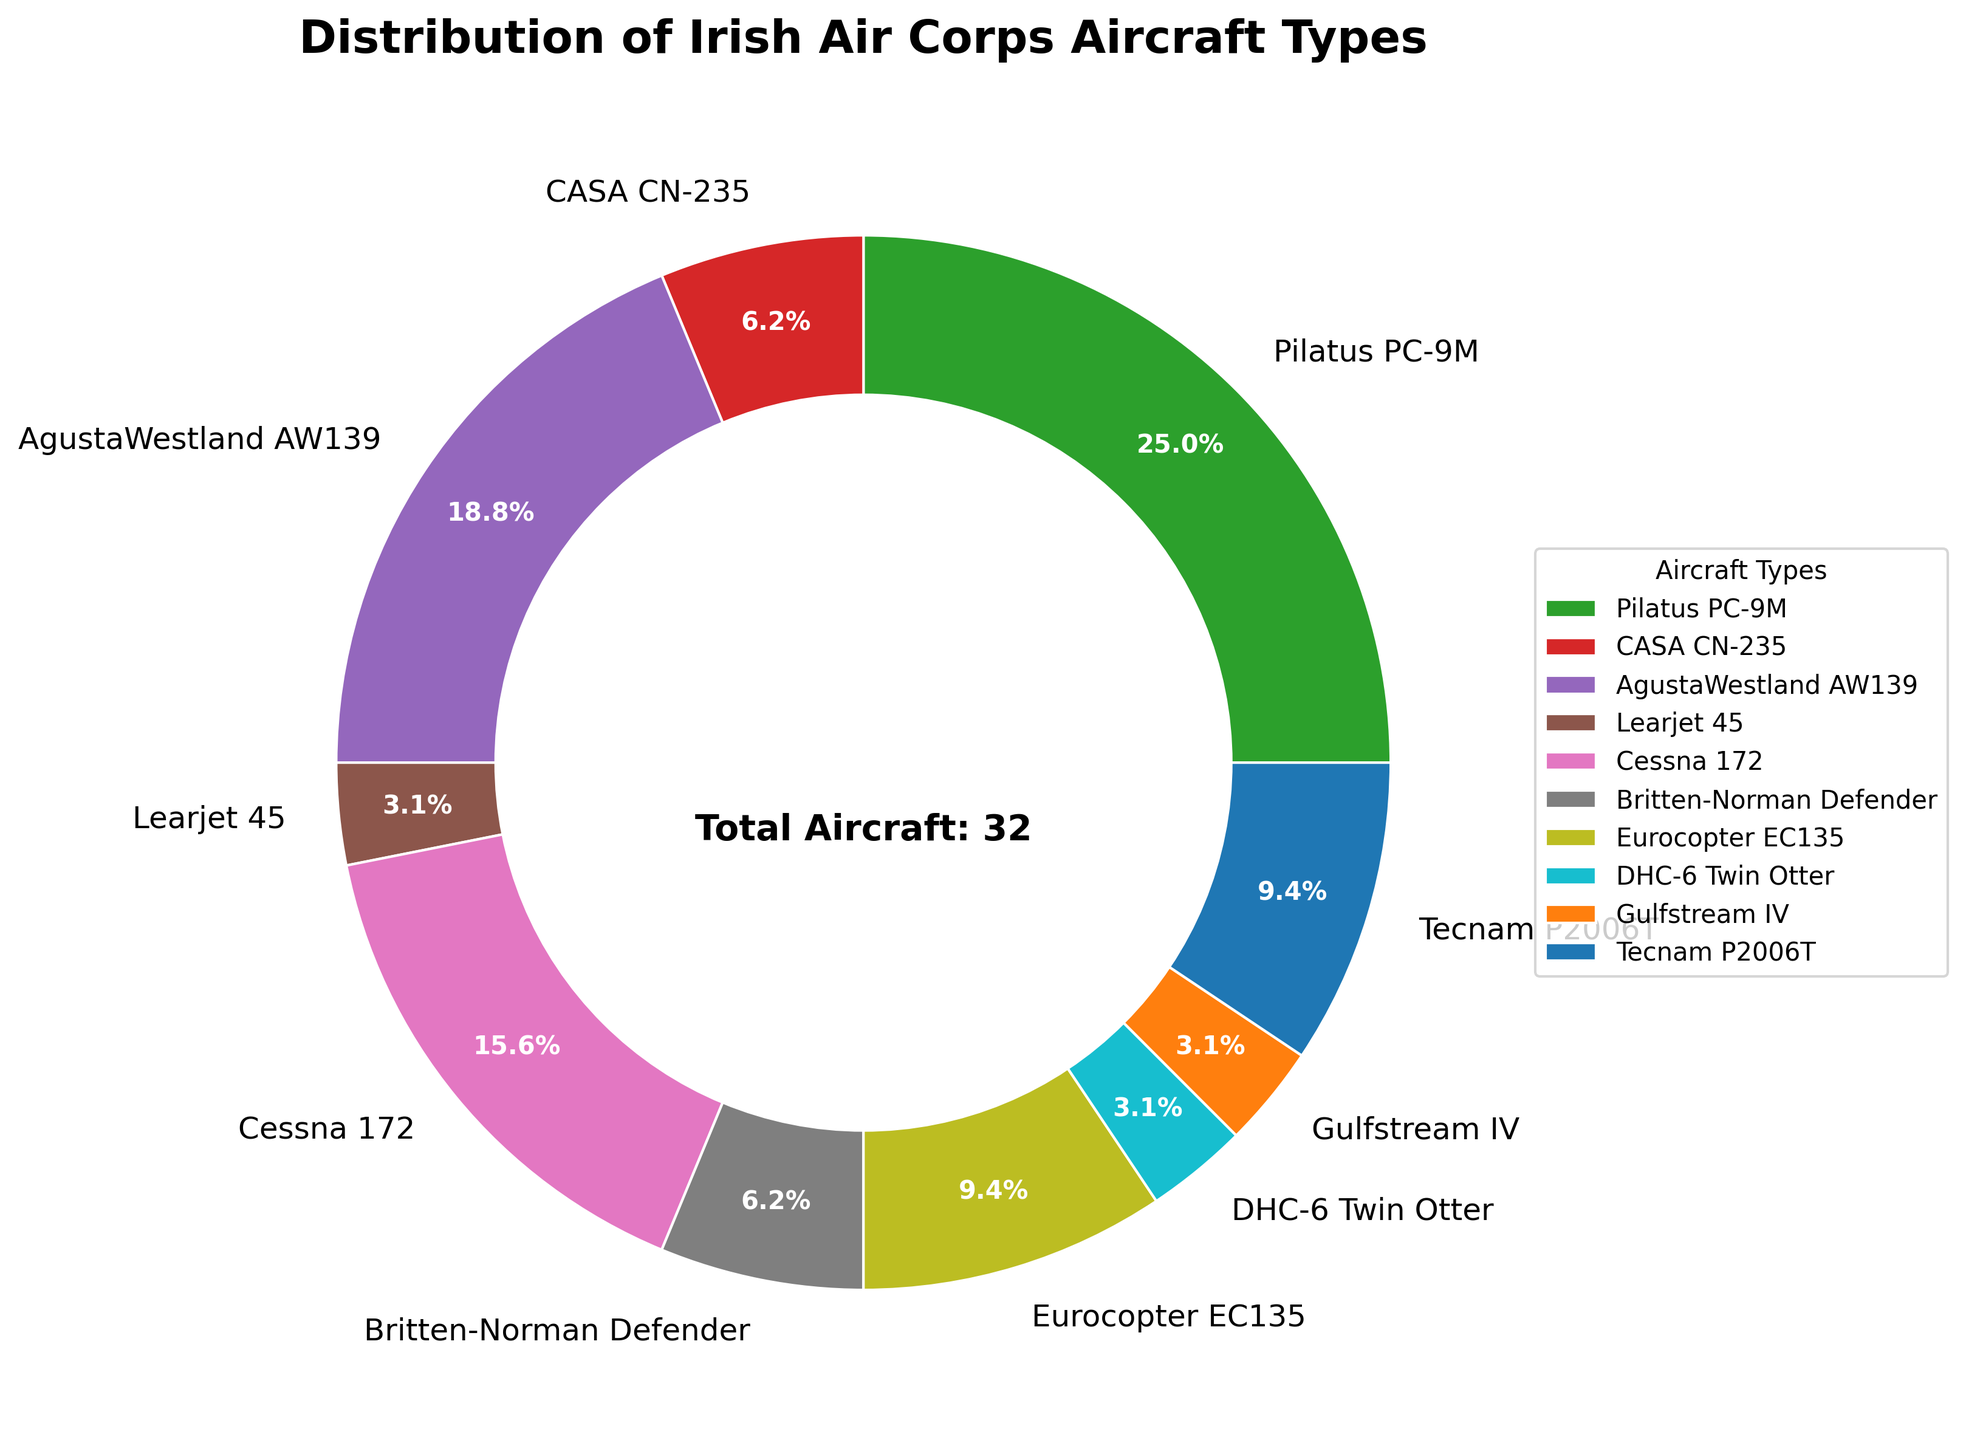Which aircraft type is the most prevalent in the Irish Air Corps? The figure shows a pie chart with different segments labeled by aircraft types. The largest segment corresponds to the Pilatus PC-9M, indicating it is the most prevalent.
Answer: Pilatus PC-9M How many more Pilatus PC-9M aircraft are in service compared to the Learjet 45 and DHC-6 Twin Otter combined? The figure indicates that there are 8 Pilatus PC-9M, 1 Learjet 45, and 1 DHC-6 Twin Otter. The difference is calculated as 8 - (1 + 1).
Answer: 6 Which aircraft types have exactly one aircraft in service? The pie chart has labels, and according to it, the Learjet 45, DHC-6 Twin Otter, and Gulfstream IV each have one aircraft in service.
Answer: Learjet 45, DHC-6 Twin Otter, Gulfstream IV Which aircraft type has exactly twice the number of aircraft in service as the Eurocopter EC135? The figure shows that the Eurocopter EC135 has 3 aircraft. Double this number is 6, which corresponds to the AgustaWestland AW139.
Answer: AgustaWestland AW139 What percentage of aircraft are from the Cessna 172 and Tecnam P2006T combined? The figure provides percentage values for each aircraft type. Sum the percentages of the Cessna 172 and Tecnam P2006T, which are 16.7% and 10.0%, respectively.
Answer: 26.7% Which color represents the CASA CN-235 on the pie chart? The CASA CN-235 segment on the pie chart can be identified by its color, which is labeled and shown as red.
Answer: Red What is the total number of aircraft in service? The pie chart has an annotation indicating the total. Alternatively, sum the segment values, which is 8+2+6+1+5+2+3+1+1+3.
Answer: 32 Are there more AgustaWestland AW139 or Cessna 172 aircraft in service? The chart shows 6 AgustaWestland AW139 aircraft and 5 Cessna 172 aircraft. AgustaWestland AW139 has more aircraft in service.
Answer: AgustaWestland AW139 If one more Learjet 45 was added, what percentage of the total would it then constitute? Currently, the Learjet 45 constitutes (1/32)*100 = 3.125%. With an additional Learjet 45, the count becomes 33 and the percentage is (2/33)*100.
Answer: Approximately 6.1% 